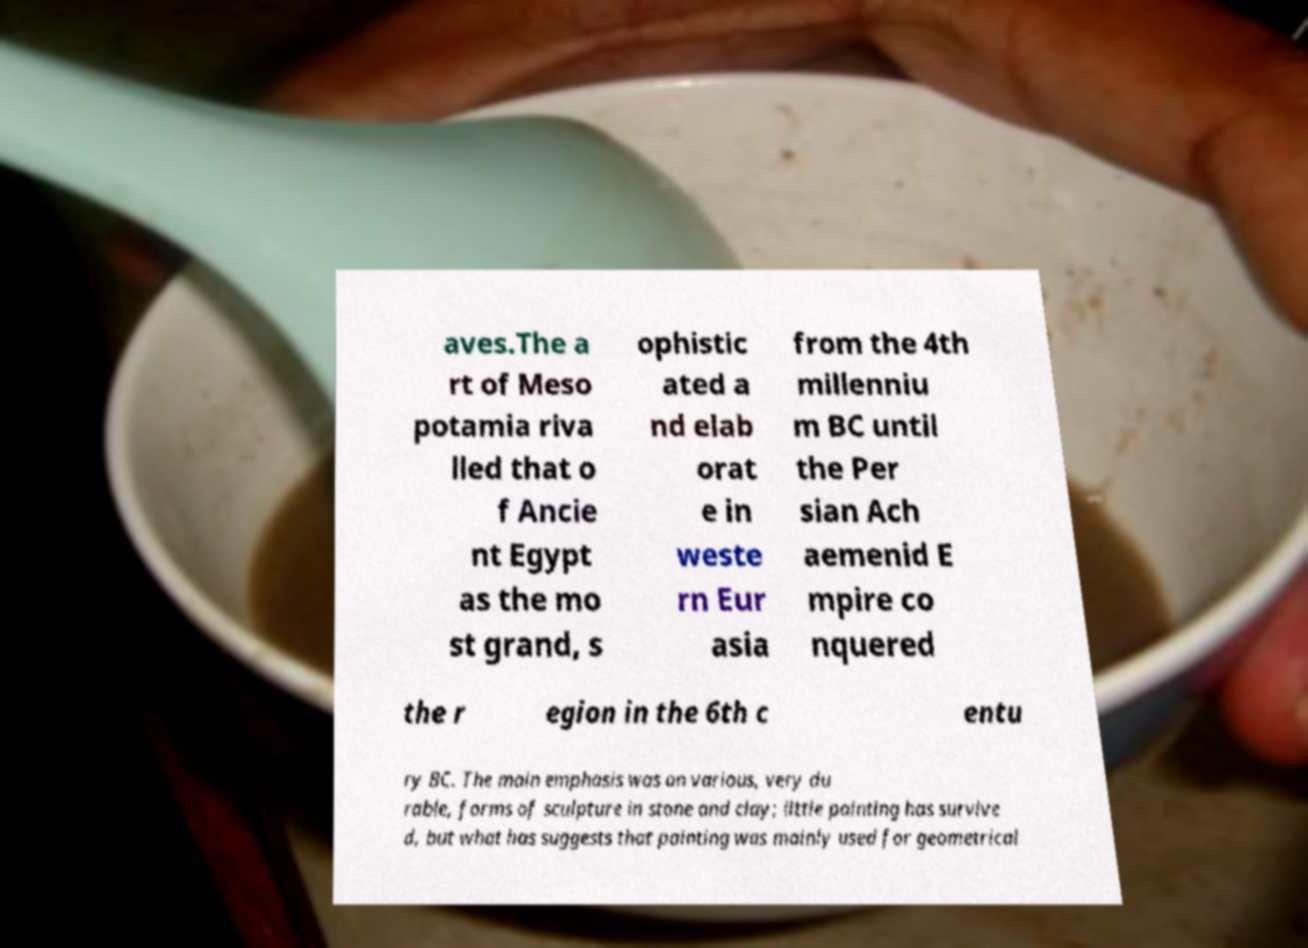Can you read and provide the text displayed in the image?This photo seems to have some interesting text. Can you extract and type it out for me? aves.The a rt of Meso potamia riva lled that o f Ancie nt Egypt as the mo st grand, s ophistic ated a nd elab orat e in weste rn Eur asia from the 4th millenniu m BC until the Per sian Ach aemenid E mpire co nquered the r egion in the 6th c entu ry BC. The main emphasis was on various, very du rable, forms of sculpture in stone and clay; little painting has survive d, but what has suggests that painting was mainly used for geometrical 